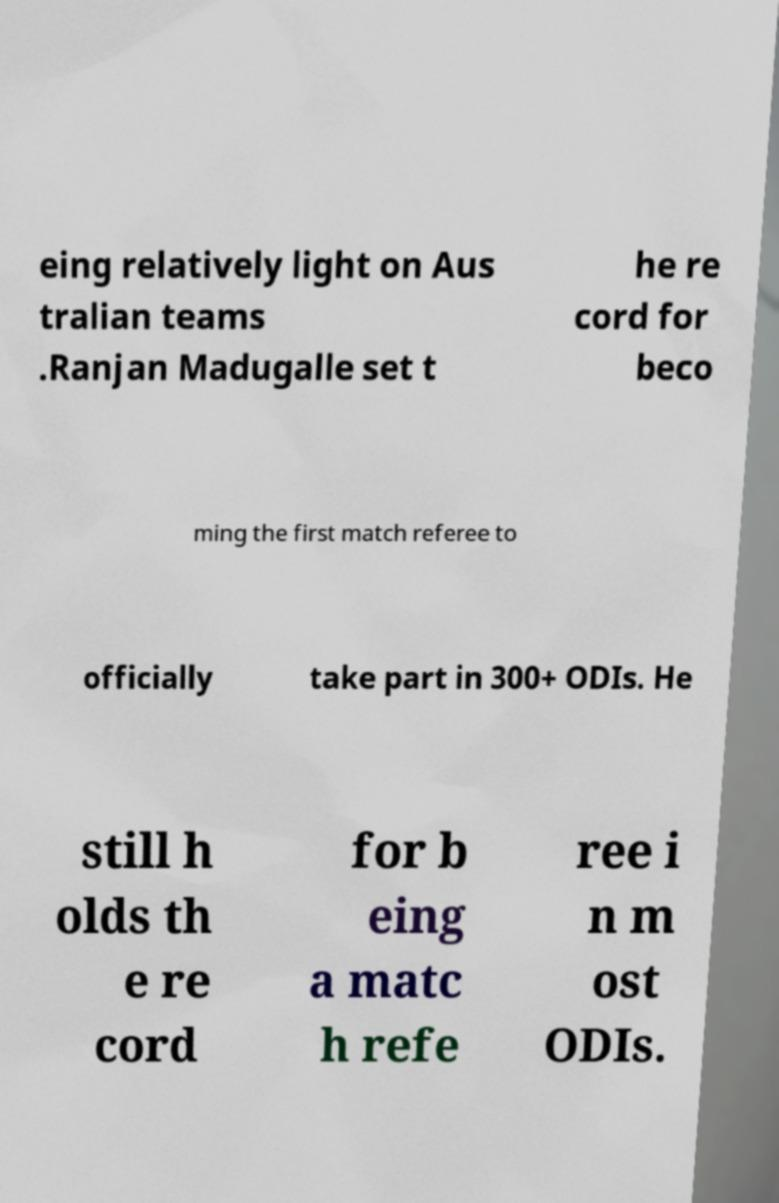Please identify and transcribe the text found in this image. eing relatively light on Aus tralian teams .Ranjan Madugalle set t he re cord for beco ming the first match referee to officially take part in 300+ ODIs. He still h olds th e re cord for b eing a matc h refe ree i n m ost ODIs. 